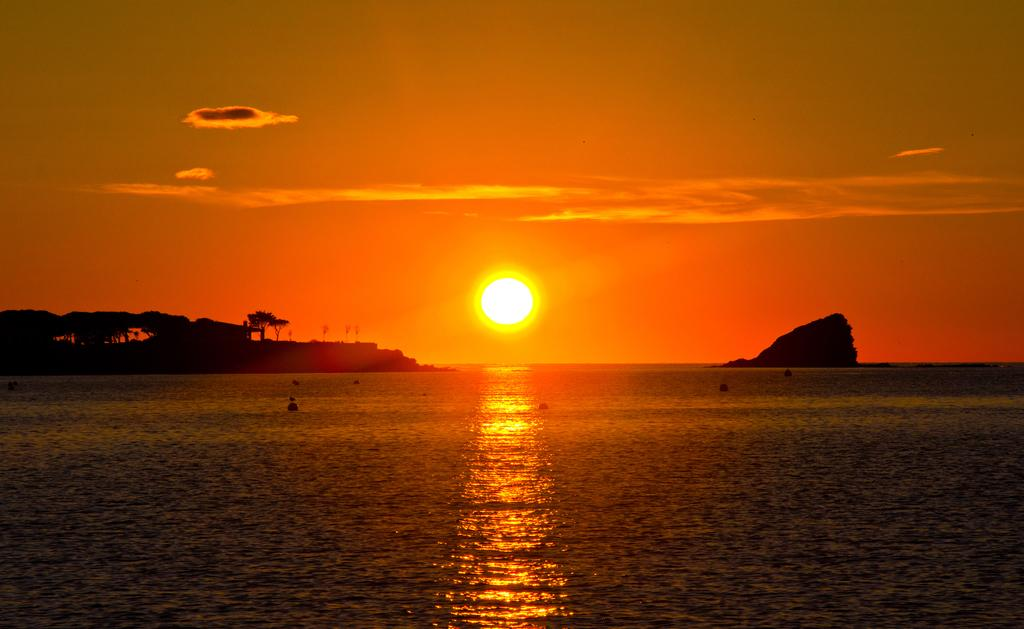What type of natural feature is the main subject of the image? There is an ocean in the image. What can be seen in the background of the image? There are trees in the background of the image. What celestial body is visible in the sky? The sun is visible in the sky. What type of needle can be seen floating on the ocean in the image? There is no needle present in the image; it features an ocean, trees in the background, and the sun in the sky. 